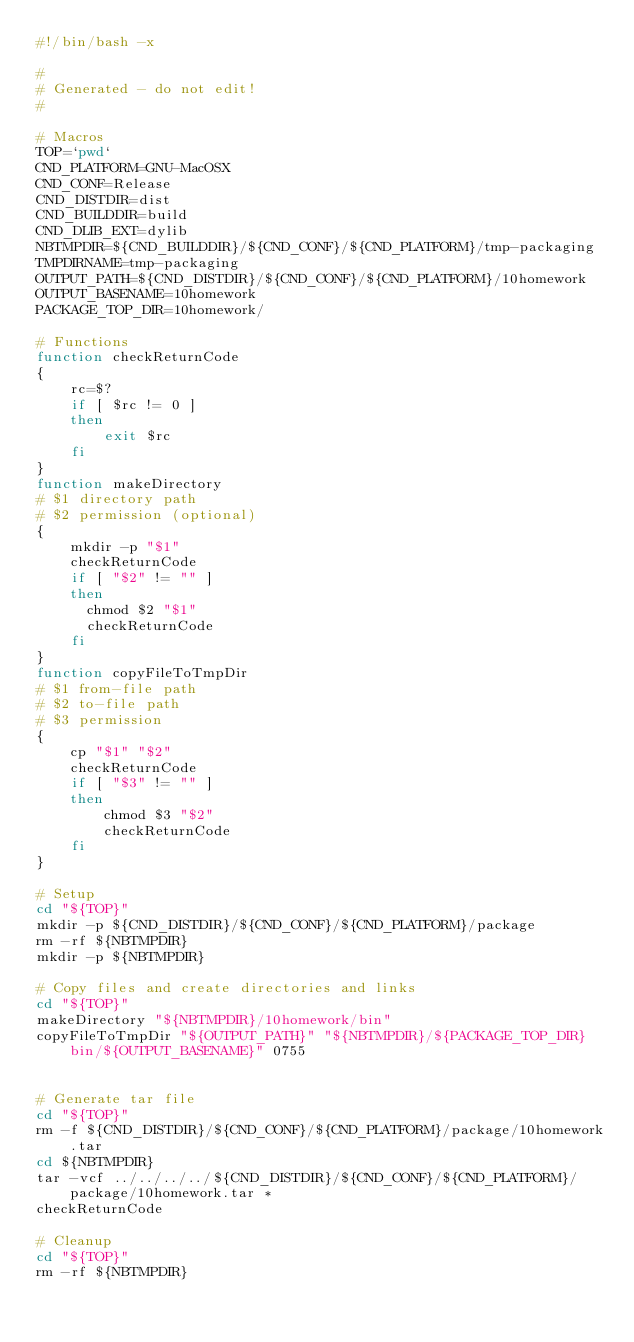<code> <loc_0><loc_0><loc_500><loc_500><_Bash_>#!/bin/bash -x

#
# Generated - do not edit!
#

# Macros
TOP=`pwd`
CND_PLATFORM=GNU-MacOSX
CND_CONF=Release
CND_DISTDIR=dist
CND_BUILDDIR=build
CND_DLIB_EXT=dylib
NBTMPDIR=${CND_BUILDDIR}/${CND_CONF}/${CND_PLATFORM}/tmp-packaging
TMPDIRNAME=tmp-packaging
OUTPUT_PATH=${CND_DISTDIR}/${CND_CONF}/${CND_PLATFORM}/10homework
OUTPUT_BASENAME=10homework
PACKAGE_TOP_DIR=10homework/

# Functions
function checkReturnCode
{
    rc=$?
    if [ $rc != 0 ]
    then
        exit $rc
    fi
}
function makeDirectory
# $1 directory path
# $2 permission (optional)
{
    mkdir -p "$1"
    checkReturnCode
    if [ "$2" != "" ]
    then
      chmod $2 "$1"
      checkReturnCode
    fi
}
function copyFileToTmpDir
# $1 from-file path
# $2 to-file path
# $3 permission
{
    cp "$1" "$2"
    checkReturnCode
    if [ "$3" != "" ]
    then
        chmod $3 "$2"
        checkReturnCode
    fi
}

# Setup
cd "${TOP}"
mkdir -p ${CND_DISTDIR}/${CND_CONF}/${CND_PLATFORM}/package
rm -rf ${NBTMPDIR}
mkdir -p ${NBTMPDIR}

# Copy files and create directories and links
cd "${TOP}"
makeDirectory "${NBTMPDIR}/10homework/bin"
copyFileToTmpDir "${OUTPUT_PATH}" "${NBTMPDIR}/${PACKAGE_TOP_DIR}bin/${OUTPUT_BASENAME}" 0755


# Generate tar file
cd "${TOP}"
rm -f ${CND_DISTDIR}/${CND_CONF}/${CND_PLATFORM}/package/10homework.tar
cd ${NBTMPDIR}
tar -vcf ../../../../${CND_DISTDIR}/${CND_CONF}/${CND_PLATFORM}/package/10homework.tar *
checkReturnCode

# Cleanup
cd "${TOP}"
rm -rf ${NBTMPDIR}
</code> 